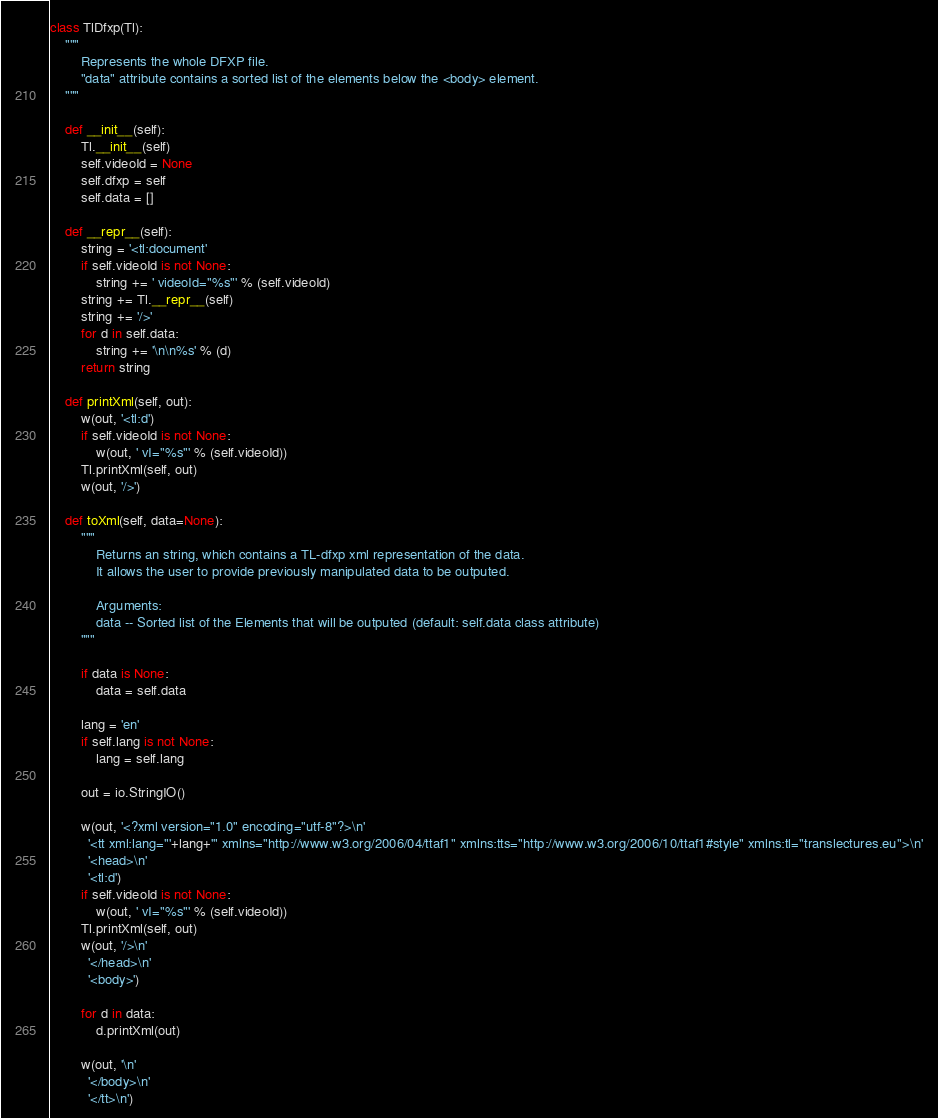<code> <loc_0><loc_0><loc_500><loc_500><_Python_>class TlDfxp(Tl):
    """
        Represents the whole DFXP file.
        "data" attribute contains a sorted list of the elements below the <body> element.
    """

    def __init__(self):
        Tl.__init__(self)
        self.videoId = None
        self.dfxp = self
        self.data = []

    def __repr__(self):
        string = '<tl:document'
        if self.videoId is not None:
            string += ' videoId="%s"' % (self.videoId)
        string += Tl.__repr__(self)
        string += '/>'
        for d in self.data:
            string += '\n\n%s' % (d)
        return string

    def printXml(self, out):
        w(out, '<tl:d')
        if self.videoId is not None:
            w(out, ' vI="%s"' % (self.videoId))
        Tl.printXml(self, out)
        w(out, '/>')

    def toXml(self, data=None):
        """ 
            Returns an string, which contains a TL-dfxp xml representation of the data.
            It allows the user to provide previously manipulated data to be outputed.

            Arguments:
            data -- Sorted list of the Elements that will be outputed (default: self.data class attribute)
        """

        if data is None:
            data = self.data

        lang = 'en'
        if self.lang is not None:
            lang = self.lang

        out = io.StringIO()

        w(out, '<?xml version="1.0" encoding="utf-8"?>\n'
          '<tt xml:lang="'+lang+'" xmlns="http://www.w3.org/2006/04/ttaf1" xmlns:tts="http://www.w3.org/2006/10/ttaf1#style" xmlns:tl="translectures.eu">\n'
          '<head>\n'
          '<tl:d')
        if self.videoId is not None:
            w(out, ' vI="%s"' % (self.videoId))
        Tl.printXml(self, out)
        w(out, '/>\n'
          '</head>\n'
          '<body>')

        for d in data:
            d.printXml(out)

        w(out, '\n'
          '</body>\n'
          '</tt>\n')
</code> 